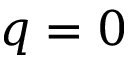Convert formula to latex. <formula><loc_0><loc_0><loc_500><loc_500>q = 0</formula> 